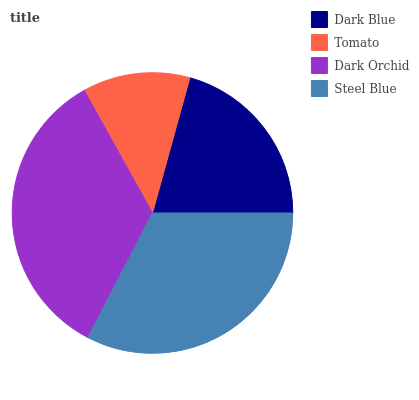Is Tomato the minimum?
Answer yes or no. Yes. Is Dark Orchid the maximum?
Answer yes or no. Yes. Is Dark Orchid the minimum?
Answer yes or no. No. Is Tomato the maximum?
Answer yes or no. No. Is Dark Orchid greater than Tomato?
Answer yes or no. Yes. Is Tomato less than Dark Orchid?
Answer yes or no. Yes. Is Tomato greater than Dark Orchid?
Answer yes or no. No. Is Dark Orchid less than Tomato?
Answer yes or no. No. Is Steel Blue the high median?
Answer yes or no. Yes. Is Dark Blue the low median?
Answer yes or no. Yes. Is Tomato the high median?
Answer yes or no. No. Is Steel Blue the low median?
Answer yes or no. No. 